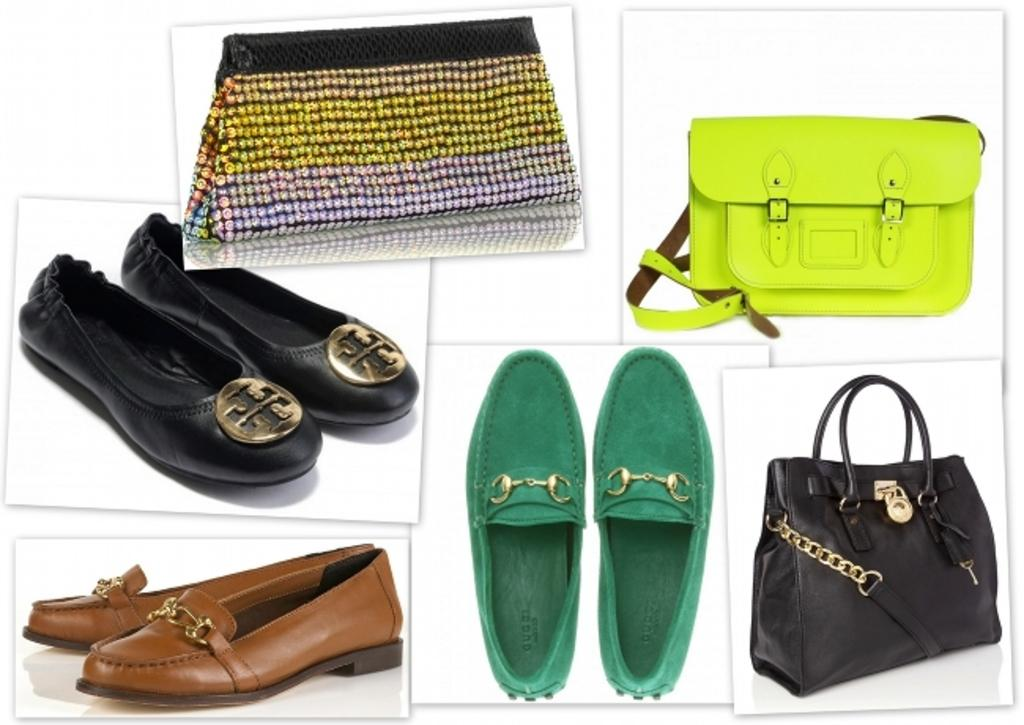What type of items can be seen in the image related to footwear? There are foot wears in the image. What colors of bags are present in the image? There are black, green, and multicolor bags in the image. What advice is given by the thunder in the image? There is no thunder present in the image, and therefore no advice can be given. How does the image show respect for the environment? The image does not show any specific actions or items that demonstrate respect for the environment. 